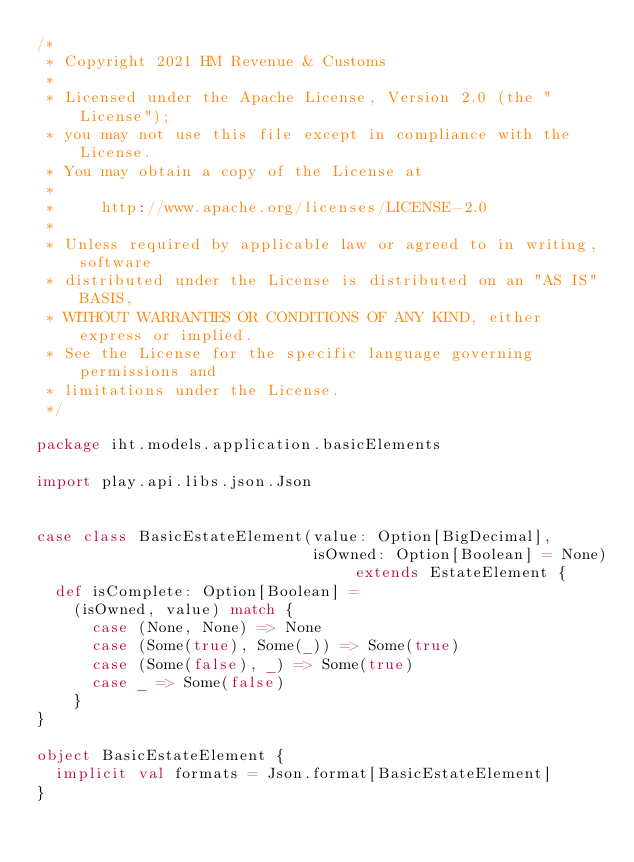Convert code to text. <code><loc_0><loc_0><loc_500><loc_500><_Scala_>/*
 * Copyright 2021 HM Revenue & Customs
 *
 * Licensed under the Apache License, Version 2.0 (the "License");
 * you may not use this file except in compliance with the License.
 * You may obtain a copy of the License at
 *
 *     http://www.apache.org/licenses/LICENSE-2.0
 *
 * Unless required by applicable law or agreed to in writing, software
 * distributed under the License is distributed on an "AS IS" BASIS,
 * WITHOUT WARRANTIES OR CONDITIONS OF ANY KIND, either express or implied.
 * See the License for the specific language governing permissions and
 * limitations under the License.
 */

package iht.models.application.basicElements

import play.api.libs.json.Json


case class BasicEstateElement(value: Option[BigDecimal],
                              isOwned: Option[Boolean] = None) extends EstateElement {
  def isComplete: Option[Boolean] =
    (isOwned, value) match {
      case (None, None) => None
      case (Some(true), Some(_)) => Some(true)
      case (Some(false), _) => Some(true)
      case _ => Some(false)
    }
}

object BasicEstateElement {
  implicit val formats = Json.format[BasicEstateElement]
}
</code> 